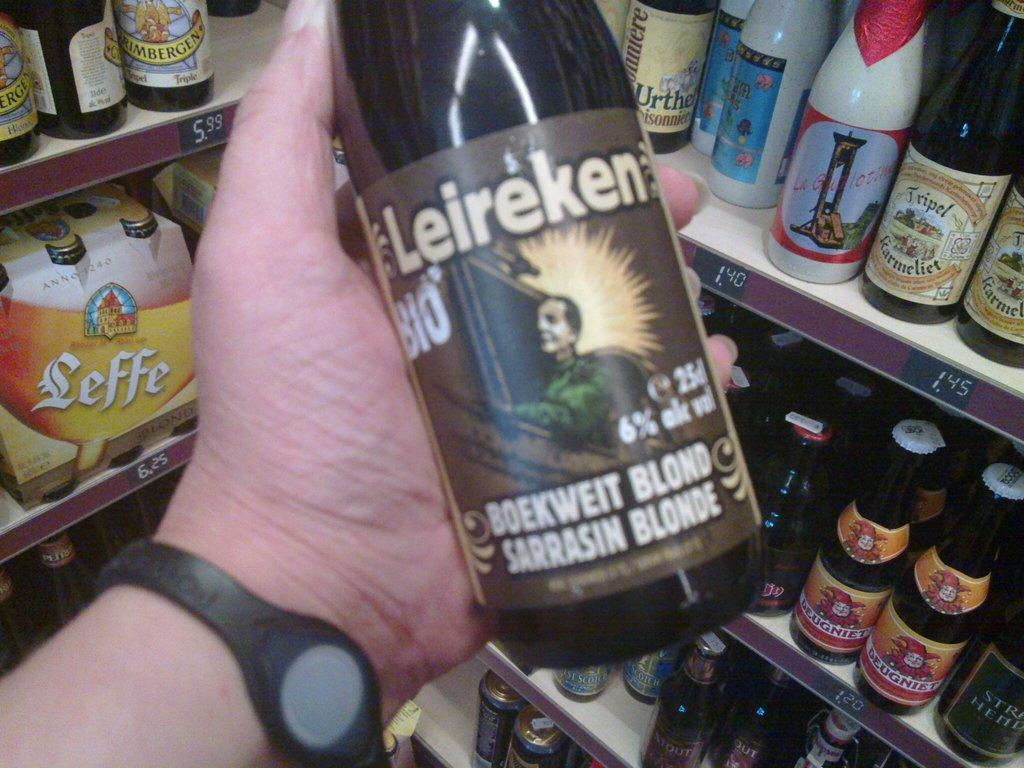Provide a one-sentence caption for the provided image. Leireken is being held in the owners hand while standing in a storage area with other spirits. 